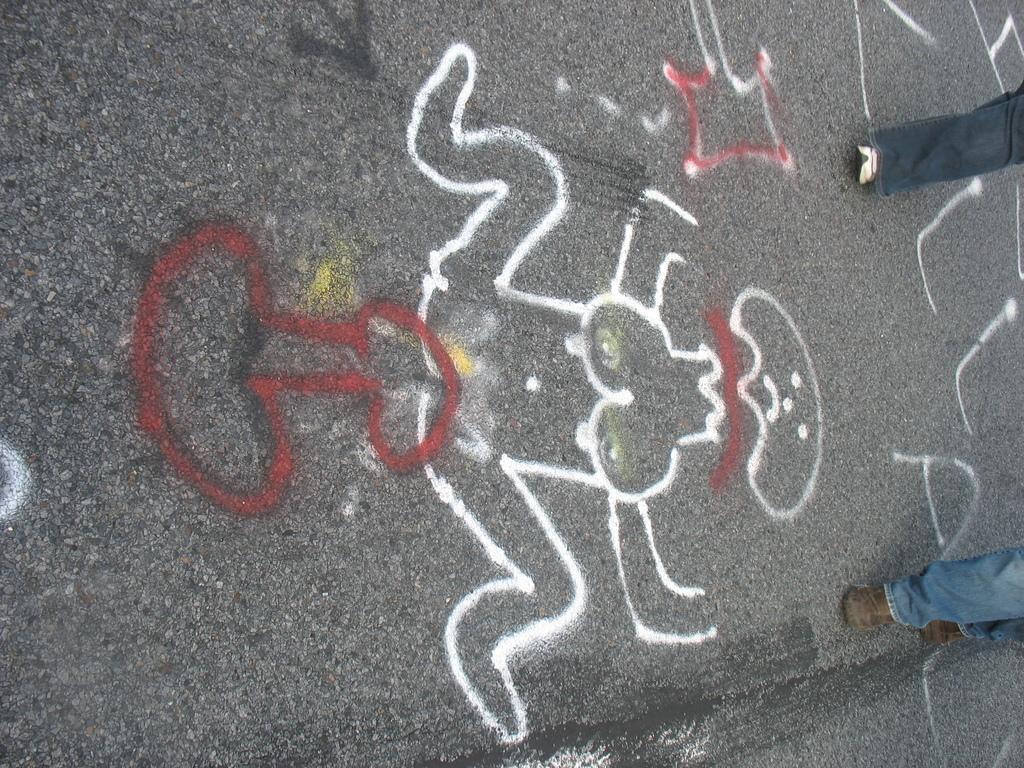How would you summarize this image in a sentence or two? In this image there is a road on the road there is some painting, and on the right side there are two persons who are walking. 